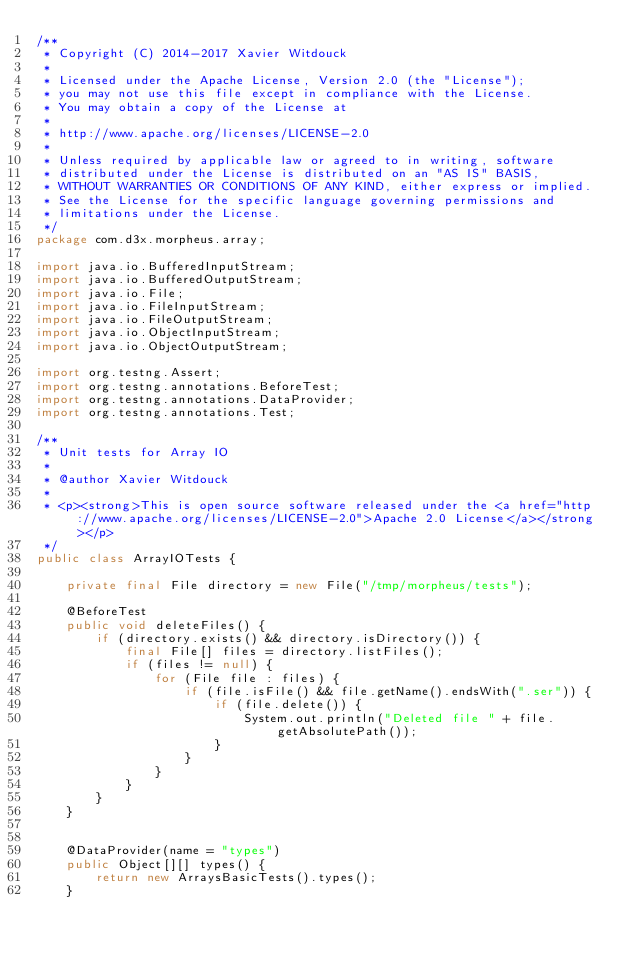<code> <loc_0><loc_0><loc_500><loc_500><_Java_>/**
 * Copyright (C) 2014-2017 Xavier Witdouck
 *
 * Licensed under the Apache License, Version 2.0 (the "License");
 * you may not use this file except in compliance with the License.
 * You may obtain a copy of the License at
 *
 * http://www.apache.org/licenses/LICENSE-2.0
 *
 * Unless required by applicable law or agreed to in writing, software
 * distributed under the License is distributed on an "AS IS" BASIS,
 * WITHOUT WARRANTIES OR CONDITIONS OF ANY KIND, either express or implied.
 * See the License for the specific language governing permissions and
 * limitations under the License.
 */
package com.d3x.morpheus.array;

import java.io.BufferedInputStream;
import java.io.BufferedOutputStream;
import java.io.File;
import java.io.FileInputStream;
import java.io.FileOutputStream;
import java.io.ObjectInputStream;
import java.io.ObjectOutputStream;

import org.testng.Assert;
import org.testng.annotations.BeforeTest;
import org.testng.annotations.DataProvider;
import org.testng.annotations.Test;

/**
 * Unit tests for Array IO
 *
 * @author Xavier Witdouck
 *
 * <p><strong>This is open source software released under the <a href="http://www.apache.org/licenses/LICENSE-2.0">Apache 2.0 License</a></strong></p>
 */
public class ArrayIOTests {

    private final File directory = new File("/tmp/morpheus/tests");

    @BeforeTest
    public void deleteFiles() {
        if (directory.exists() && directory.isDirectory()) {
            final File[] files = directory.listFiles();
            if (files != null) {
                for (File file : files) {
                    if (file.isFile() && file.getName().endsWith(".ser")) {
                        if (file.delete()) {
                            System.out.println("Deleted file " + file.getAbsolutePath());
                        }
                    }
                }
            }
        }
    }


    @DataProvider(name = "types")
    public Object[][] types() {
        return new ArraysBasicTests().types();
    }

</code> 